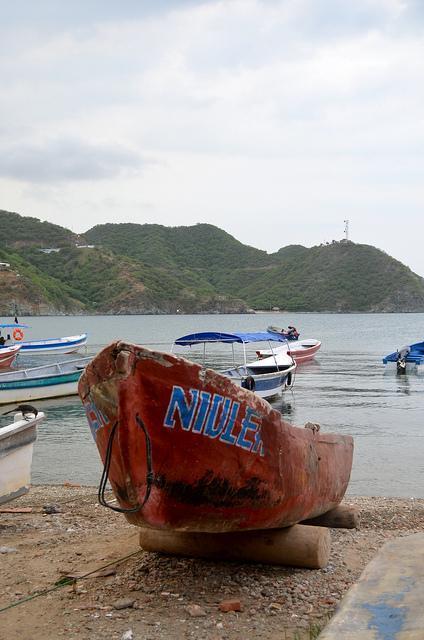How many boats are there?
Give a very brief answer. 4. How many trucks are there?
Give a very brief answer. 0. 